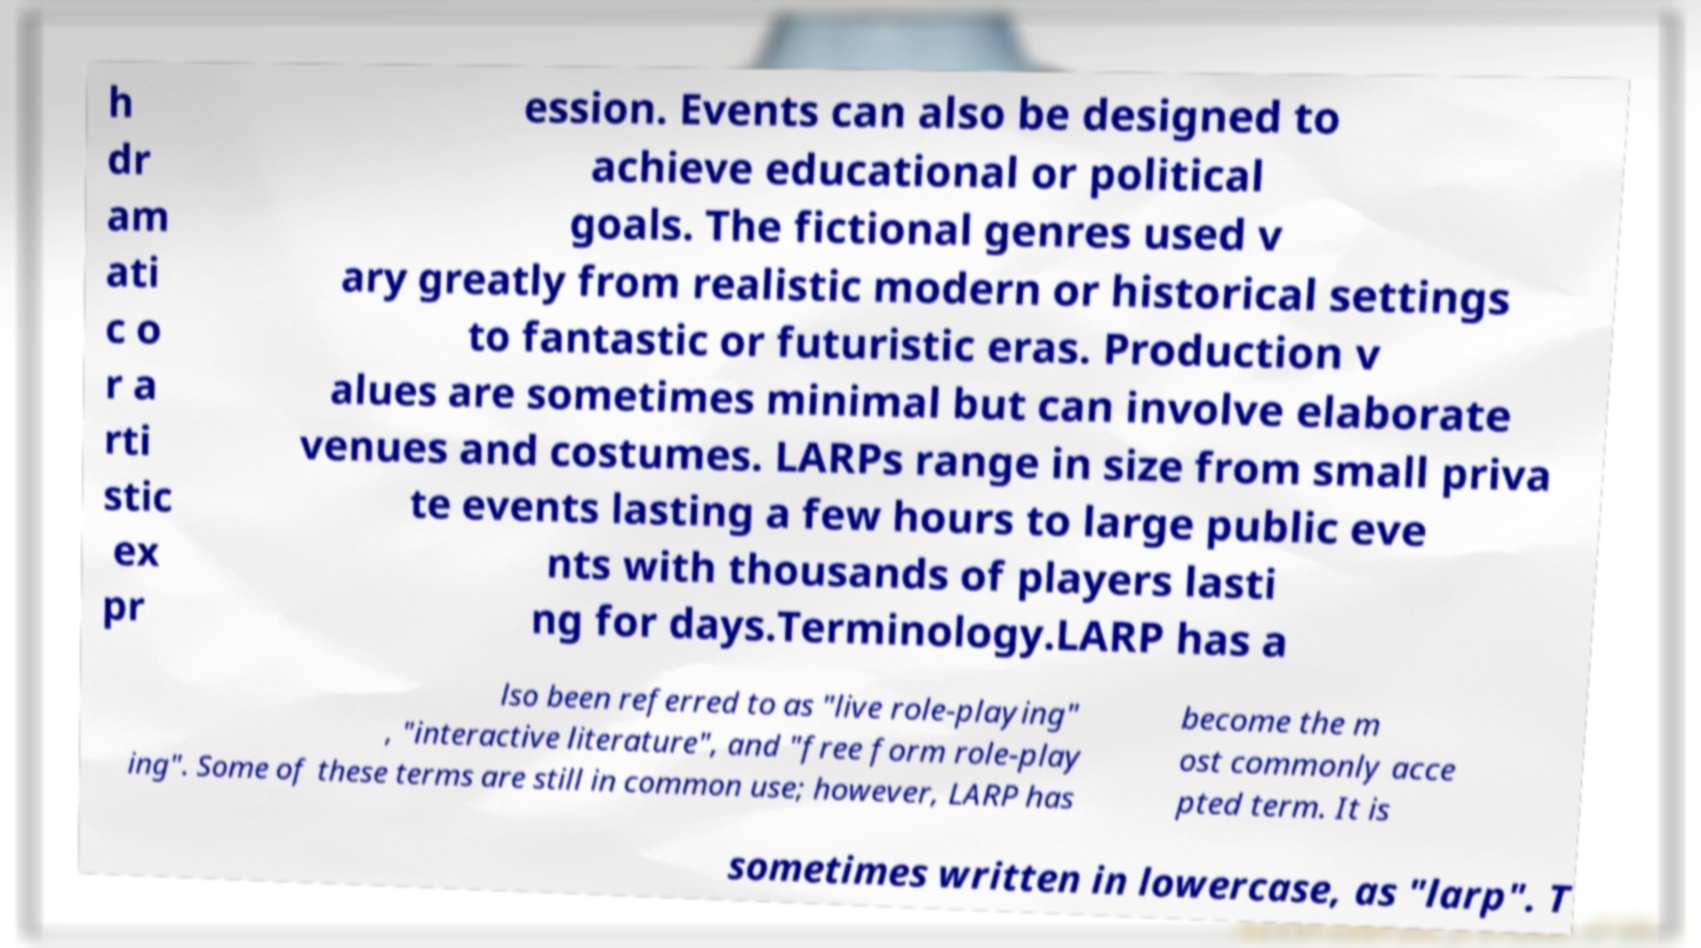What messages or text are displayed in this image? I need them in a readable, typed format. h dr am ati c o r a rti stic ex pr ession. Events can also be designed to achieve educational or political goals. The fictional genres used v ary greatly from realistic modern or historical settings to fantastic or futuristic eras. Production v alues are sometimes minimal but can involve elaborate venues and costumes. LARPs range in size from small priva te events lasting a few hours to large public eve nts with thousands of players lasti ng for days.Terminology.LARP has a lso been referred to as "live role-playing" , "interactive literature", and "free form role-play ing". Some of these terms are still in common use; however, LARP has become the m ost commonly acce pted term. It is sometimes written in lowercase, as "larp". T 